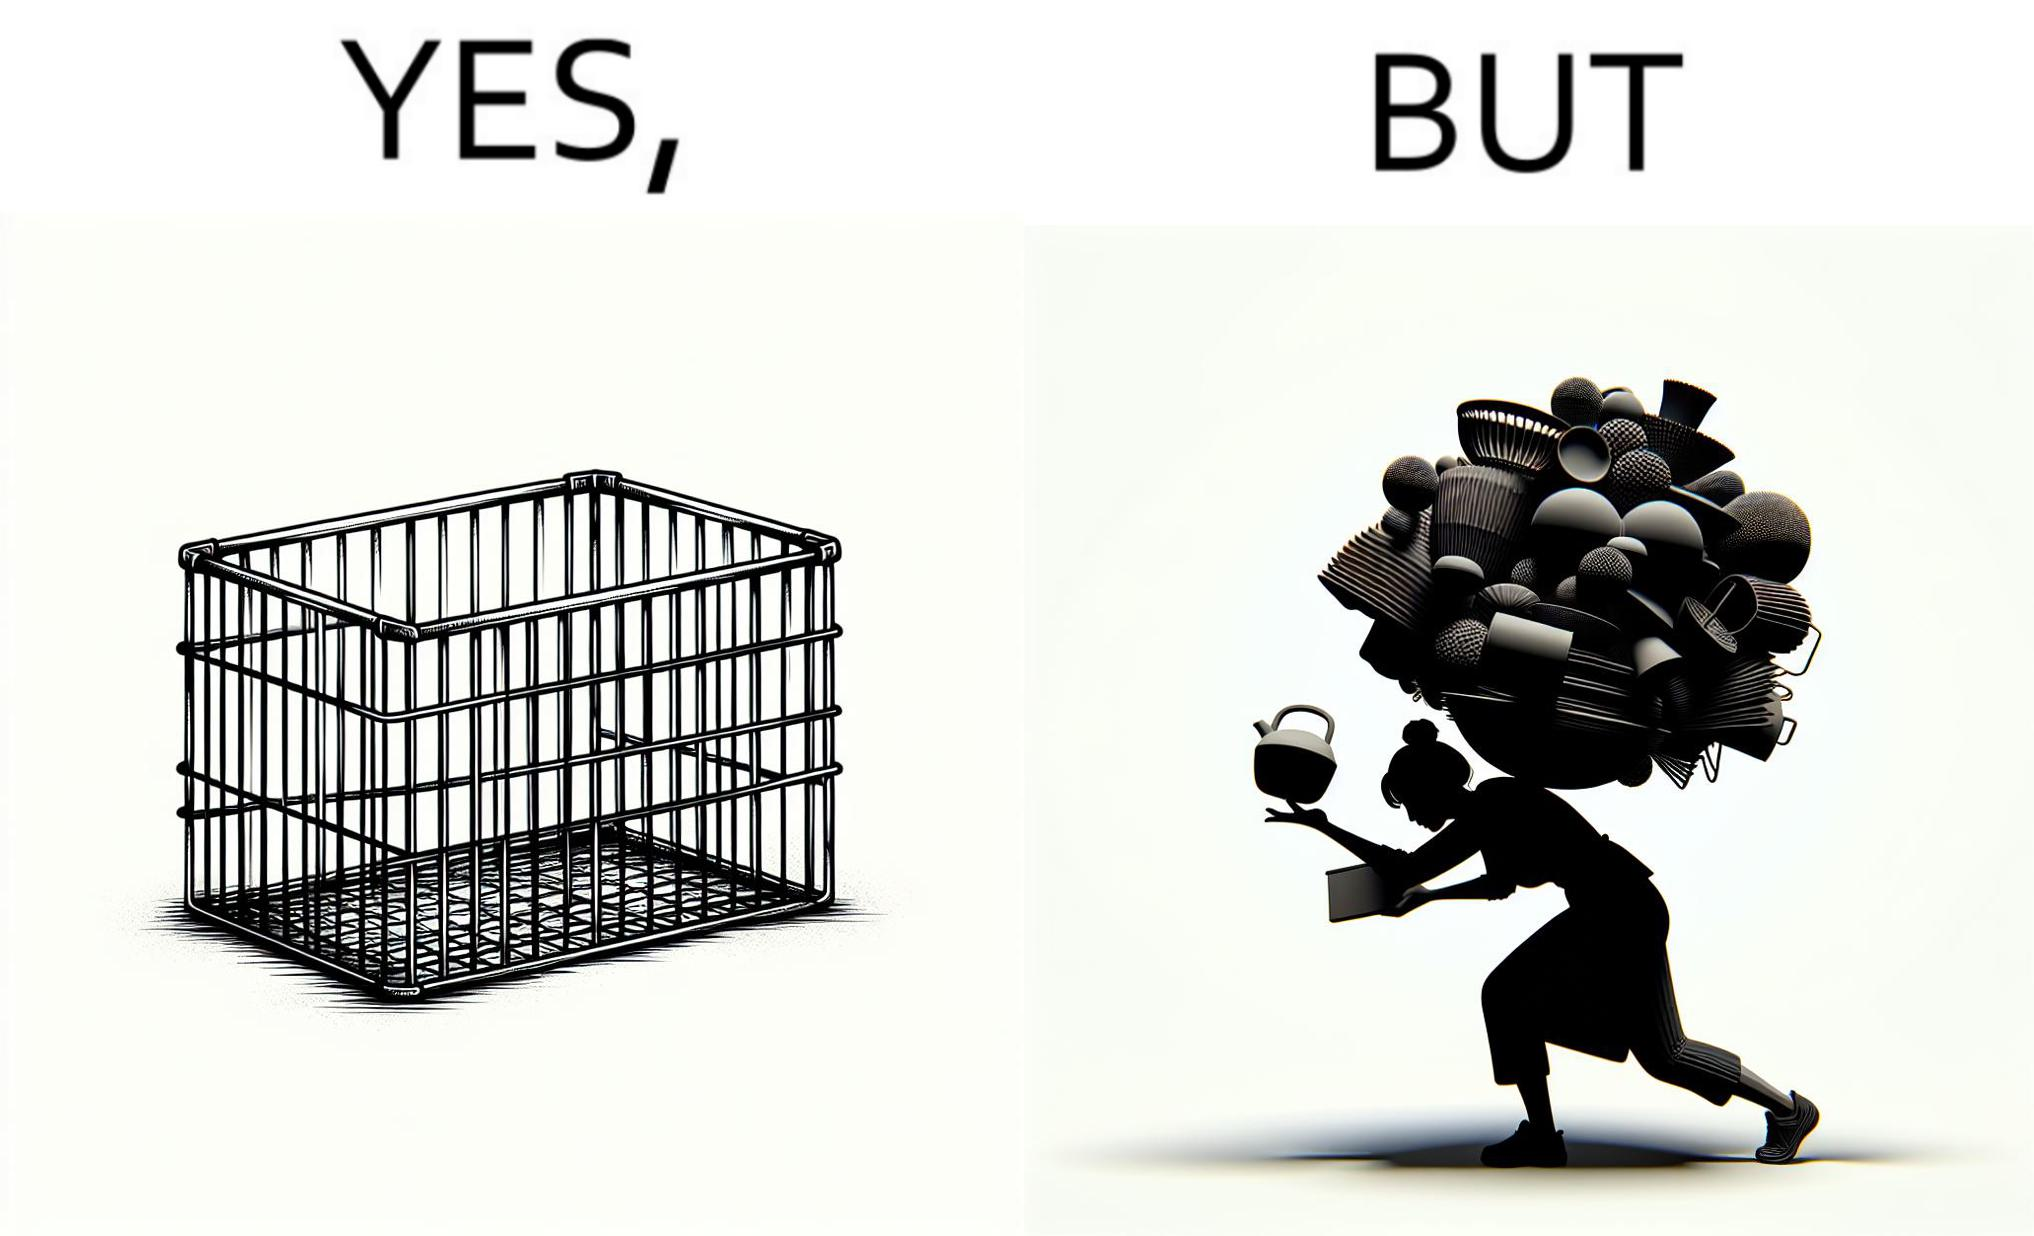Would you classify this image as satirical? Yes, this image is satirical. 